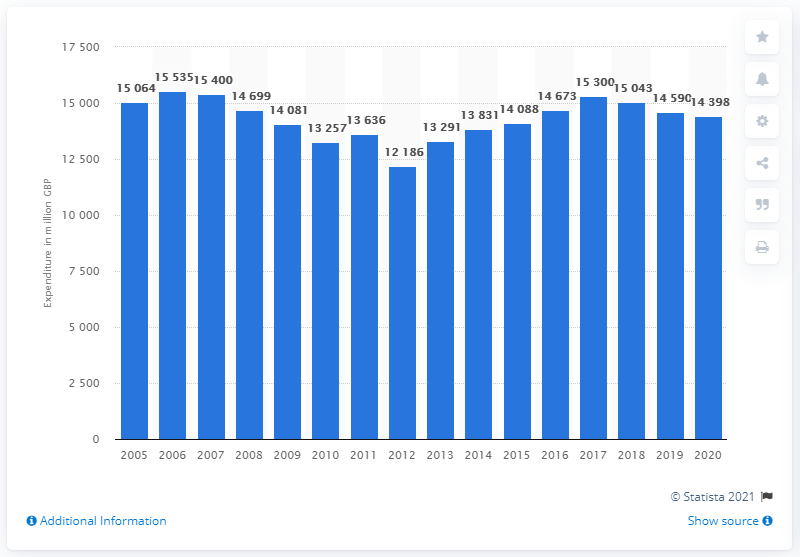Mention a couple of crucial points in this snapshot. In 2020, the value of furniture and furnishings in the UK was 14,398. 